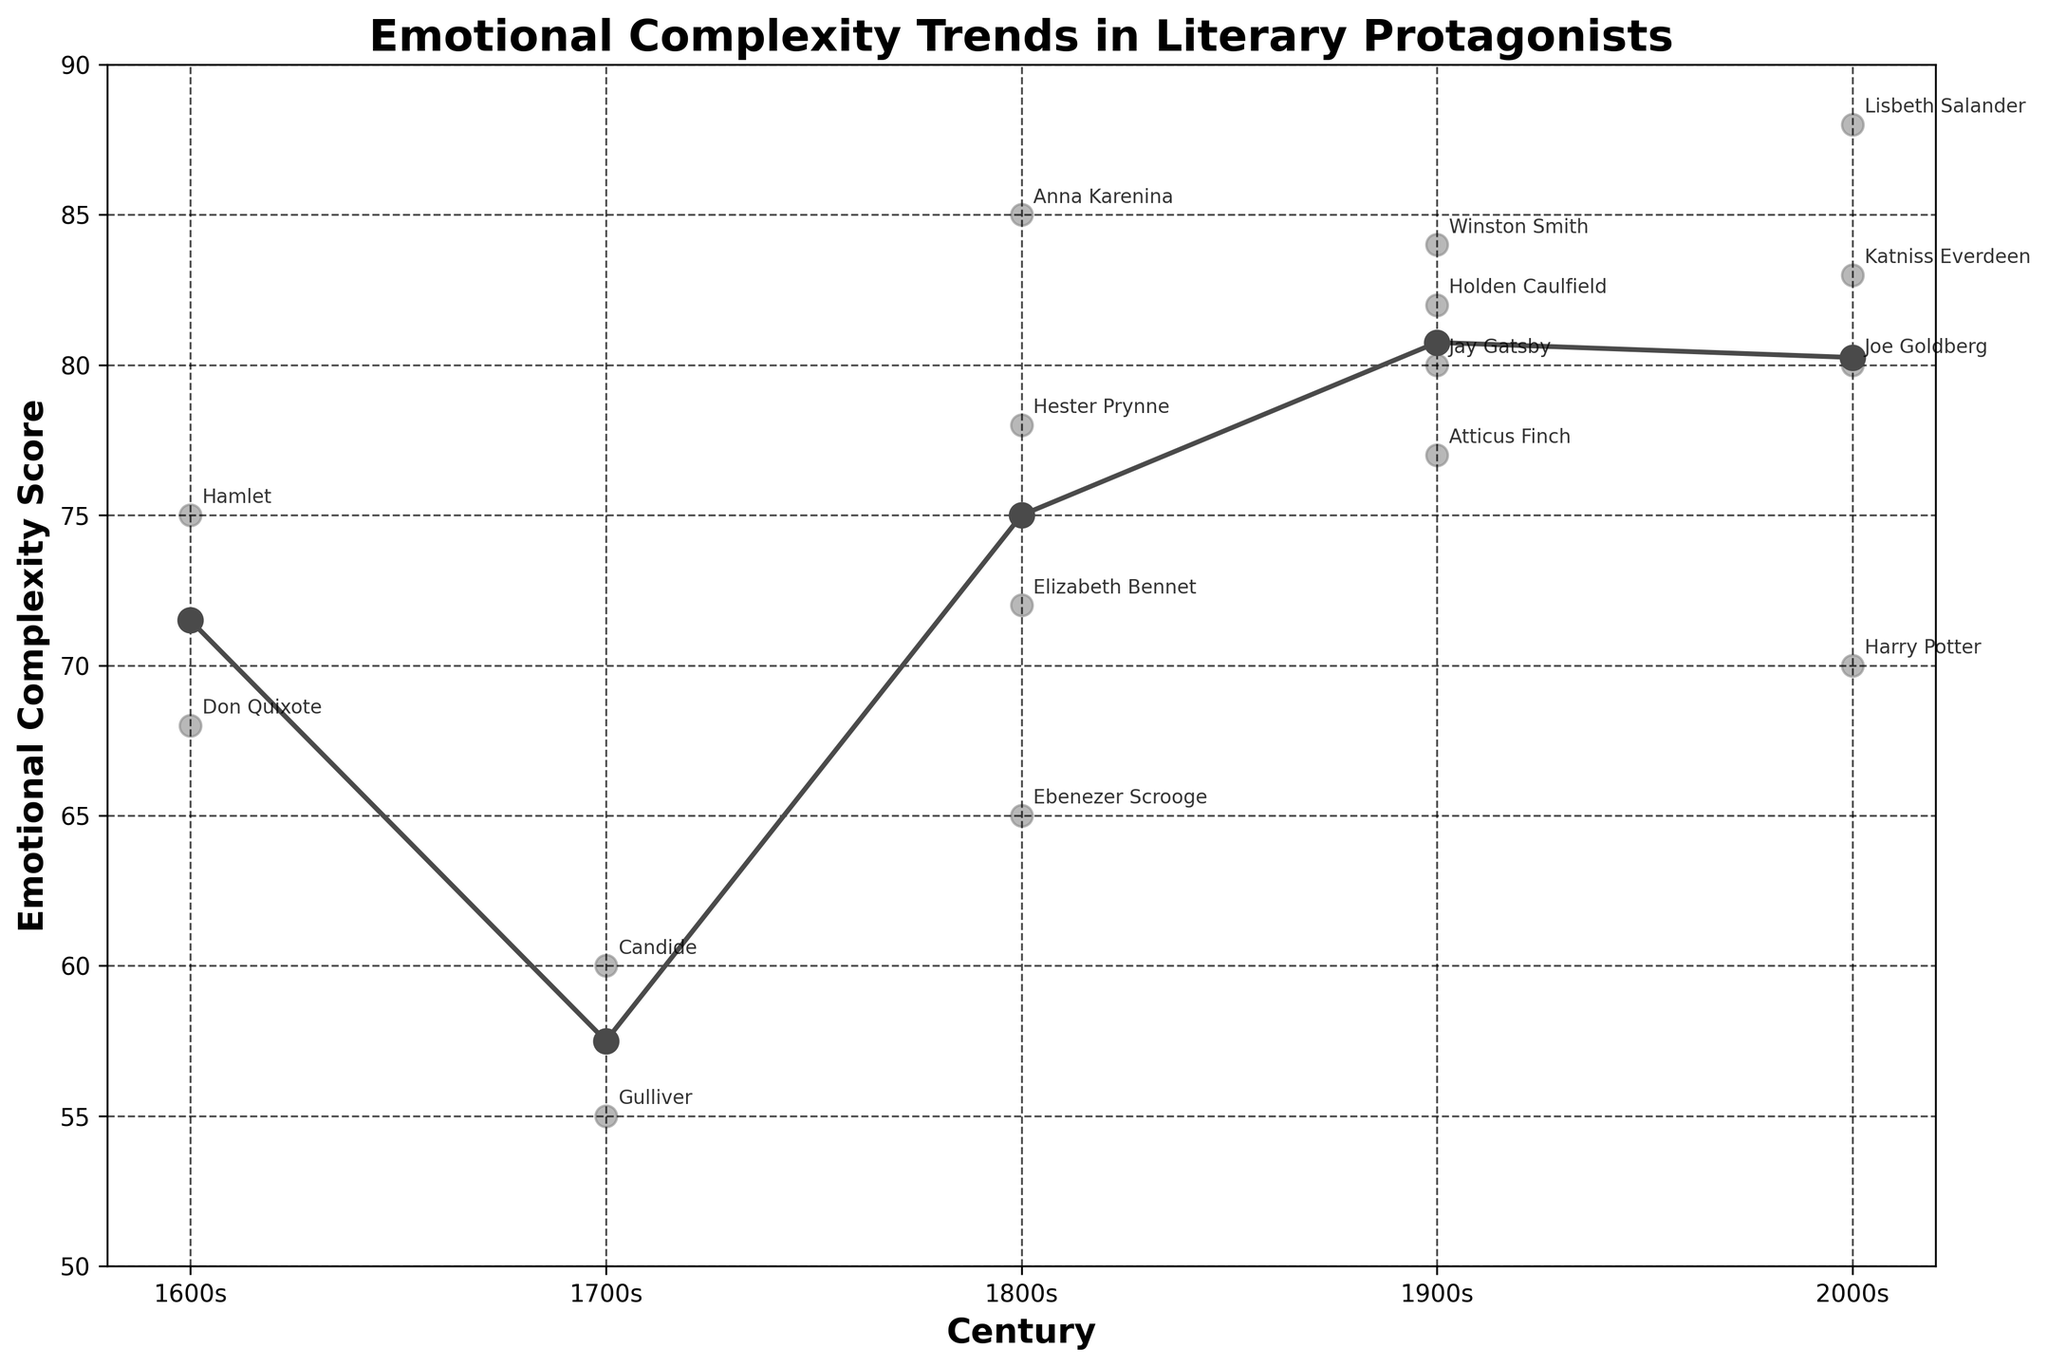What is the title of the plot? The title of the plot is written at the top of the figure. It reads "Emotional Complexity Trends in Literary Protagonists".
Answer: Emotional Complexity Trends in Literary Protagonists How many unique centuries are displayed in the plot? The x-axis of the plot shows the unique centuries which are labeled. We can count them visually: 1600s, 1700s, 1800s, 1900s, and 2000s. There are 5 unique centuries.
Answer: 5 Which protagonist has the highest emotional complexity score? By examining the plot and looking for the data point that is the highest on the y-axis, we see that Lisbeth Salander has the highest emotional complexity score of 88 in the 2000s.
Answer: Lisbeth Salander What is the average emotional complexity score for the 1800s century? The average emotional complexity score for the 1800s can be found by adding the individual scores for protagonists in the 1800s and dividing by the number of protagonists. The scores are 72, 85, 65, and 78. The average is (72 + 85 + 65 + 78) / 4 = 75.
Answer: 75 Which century shows the lowest average emotional complexity score? We calculate the average emotional complexity score for each century and compare them. The scores are 1600s: (75+68)/2 = 71.5, 1700s: (55+60)/2 = 57.5, 1800s: 75, 1900s: (80+82+77+84)/4 = 80.75, 2000s: (70+88+83+80)/4 = 80.25. The lowest is the 1700s with an average of 57.5.
Answer: 1700s How does the emotional complexity score trend from the 1600s to the 2000s? By observing the plot, we note the general direction of the line connecting average scores over the centuries. The score starts at around 71.5, dips to 57.5, increases to 75, then rises significantly over the next two centuries (80.75 and 80.25). The trend shows an overall increase with a dip in the 1700s.
Answer: Increasing with a dip in the 1700s Which century has the most diverse range of emotional complexity scores? Diversity in range can be assessed by noting the difference between the highest and lowest emotional complexity scores within a century. 1600s: (75-68) = 7, 1700s: (60-55) = 5, 1800s: (85-65) = 20, 1900s: (84-77) = 7, 2000s: (88-70) = 18. The 1800s have the most diverse range with a difference of 20.
Answer: 1800s Which decade shows a protagonist with an emotional complexity score of 82? By looking at the specific annotations, Holden Caulfield in the 1900s is marked at a score of 82.
Answer: 1900s What is the difference in emotional complexity scores between Hamlet and Harry Potter? Hamlet's score is 75 (1600s), and Harry Potter's score is 70 (2000s). The difference is 75 - 70 = 5.
Answer: 5 